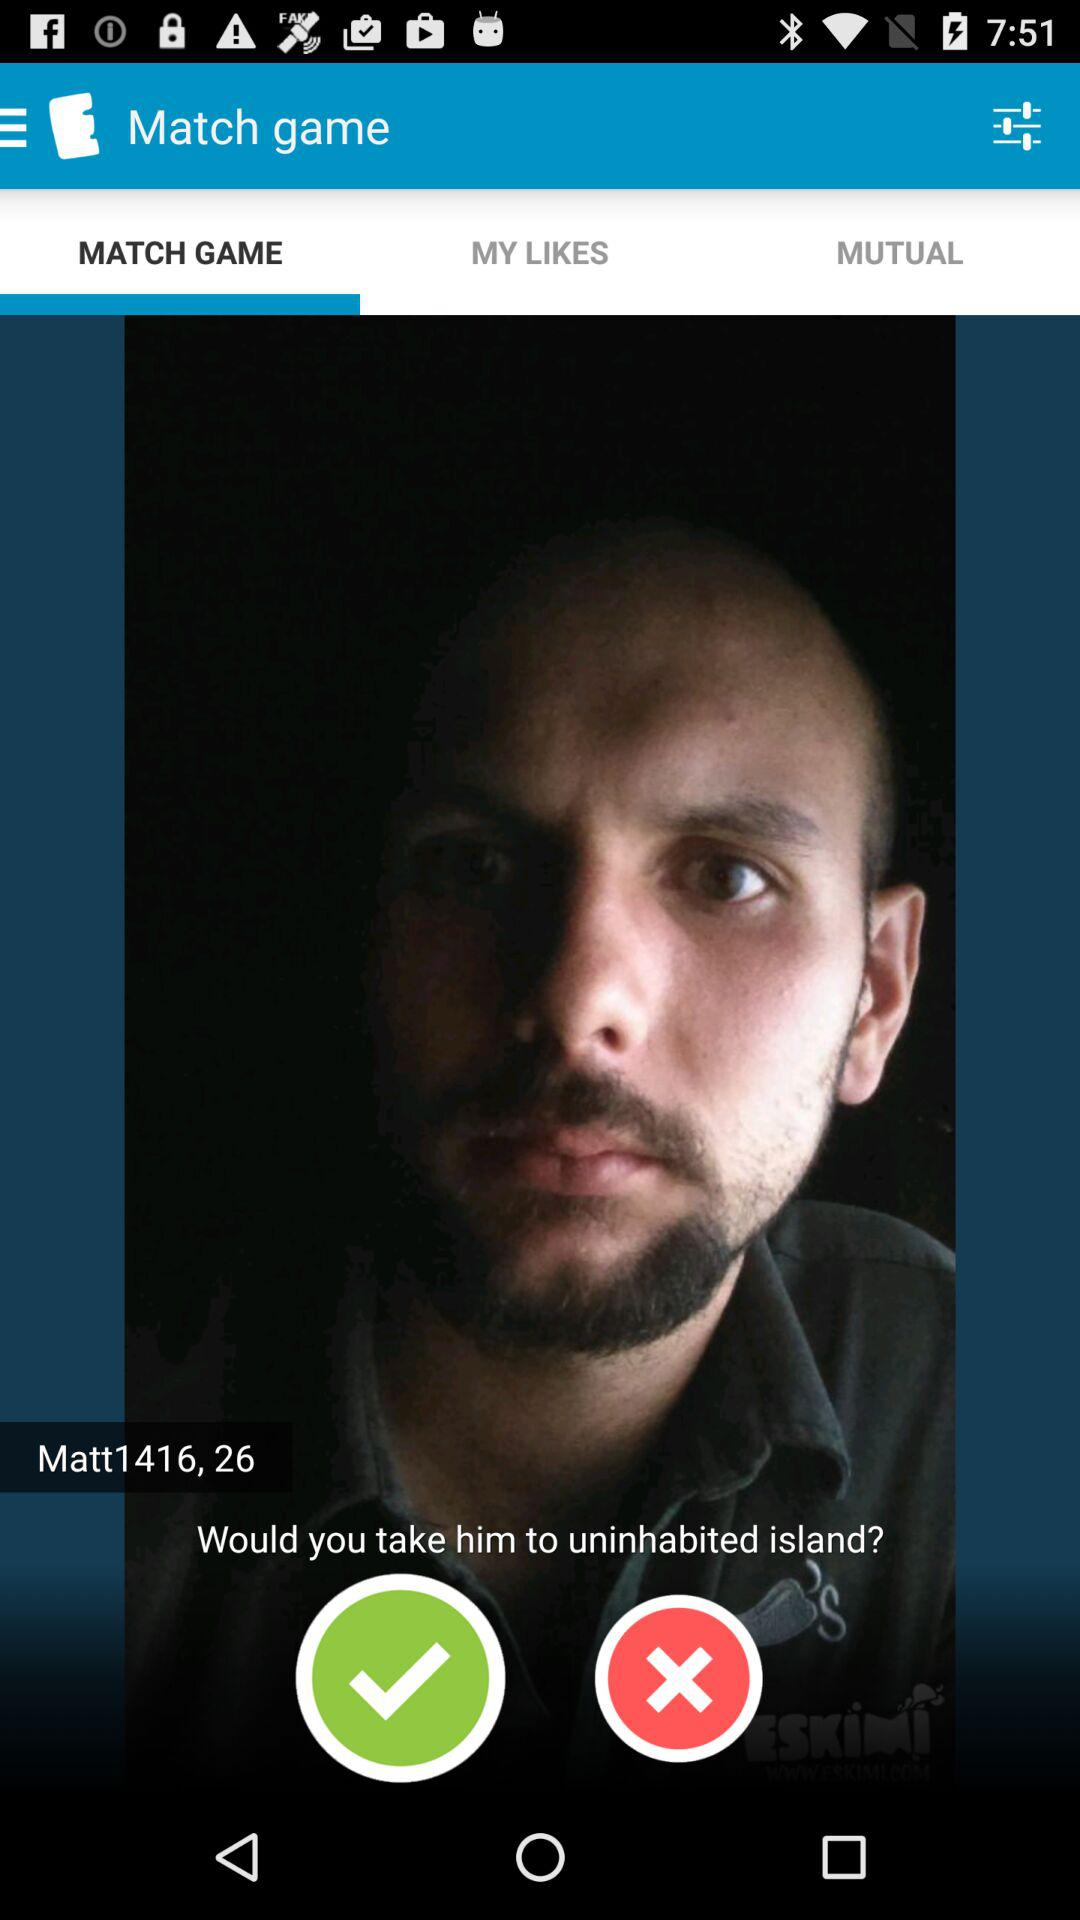What is the username? The username is "Matt1416". 